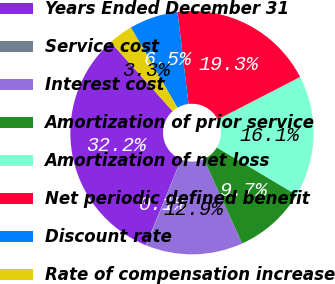Convert chart. <chart><loc_0><loc_0><loc_500><loc_500><pie_chart><fcel>Years Ended December 31<fcel>Service cost<fcel>Interest cost<fcel>Amortization of prior service<fcel>Amortization of net loss<fcel>Net periodic defined benefit<fcel>Discount rate<fcel>Rate of compensation increase<nl><fcel>32.16%<fcel>0.06%<fcel>12.9%<fcel>9.69%<fcel>16.11%<fcel>19.32%<fcel>6.48%<fcel>3.27%<nl></chart> 